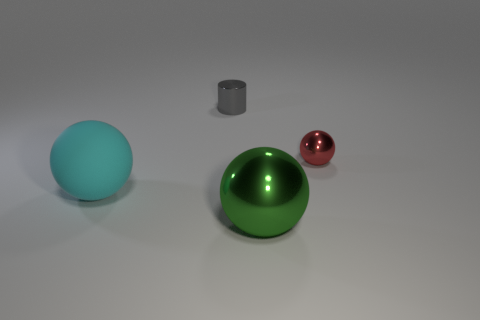Add 2 small red balls. How many objects exist? 6 Subtract all balls. How many objects are left? 1 Add 2 tiny red objects. How many tiny red objects exist? 3 Subtract 0 brown blocks. How many objects are left? 4 Subtract all big blue rubber blocks. Subtract all cyan rubber things. How many objects are left? 3 Add 3 metal cylinders. How many metal cylinders are left? 4 